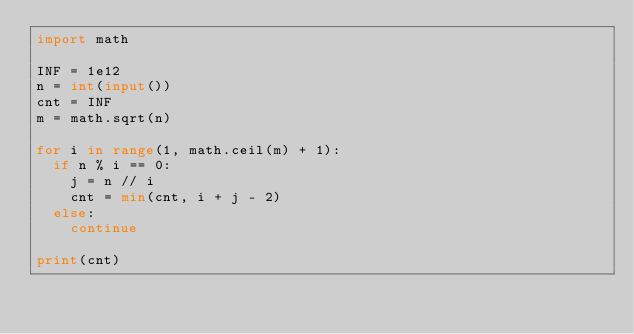Convert code to text. <code><loc_0><loc_0><loc_500><loc_500><_Python_>import math

INF = 1e12
n = int(input())
cnt = INF
m = math.sqrt(n)

for i in range(1, math.ceil(m) + 1):
  if n % i == 0:
    j = n // i
    cnt = min(cnt, i + j - 2)
  else:
    continue

print(cnt)</code> 